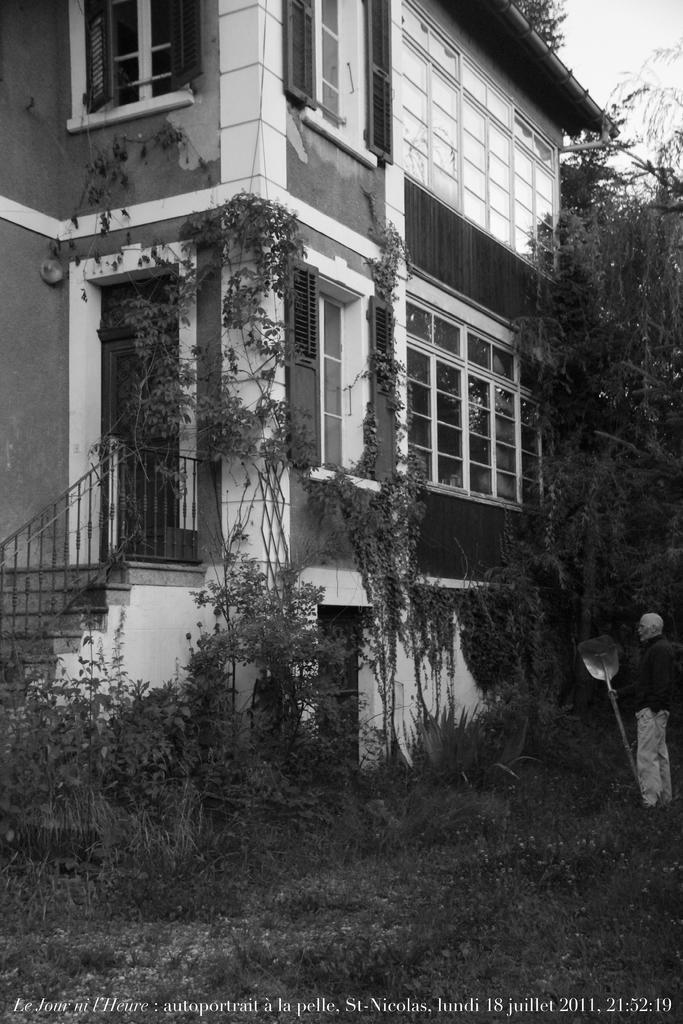Describe this image in one or two sentences. This is a black and white image. Here I can see a building. On the right side there are some trees and a man standing by holding a metal object in the hand. At the bottom of the image I can see the grass. 